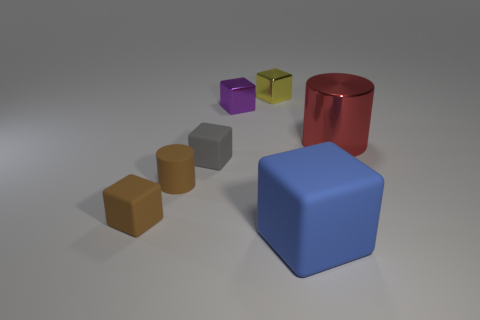Are there any cubes made of the same material as the small purple thing?
Your answer should be very brief. Yes. There is a yellow block that is the same size as the gray block; what is it made of?
Keep it short and to the point. Metal. What is the material of the cylinder behind the cylinder left of the big blue matte thing?
Make the answer very short. Metal. Is the shape of the small object in front of the brown matte cylinder the same as  the red object?
Offer a terse response. No. The cylinder that is the same material as the small gray cube is what color?
Keep it short and to the point. Brown. There is a big object behind the tiny gray thing; what is its material?
Your answer should be compact. Metal. Does the large blue matte object have the same shape as the metal object that is behind the small purple metal block?
Offer a very short reply. Yes. There is a tiny cube that is both behind the big red metallic object and left of the small yellow thing; what is its material?
Keep it short and to the point. Metal. What color is the block that is the same size as the red metallic cylinder?
Your response must be concise. Blue. Are the big block and the cylinder that is on the right side of the yellow thing made of the same material?
Offer a very short reply. No. 